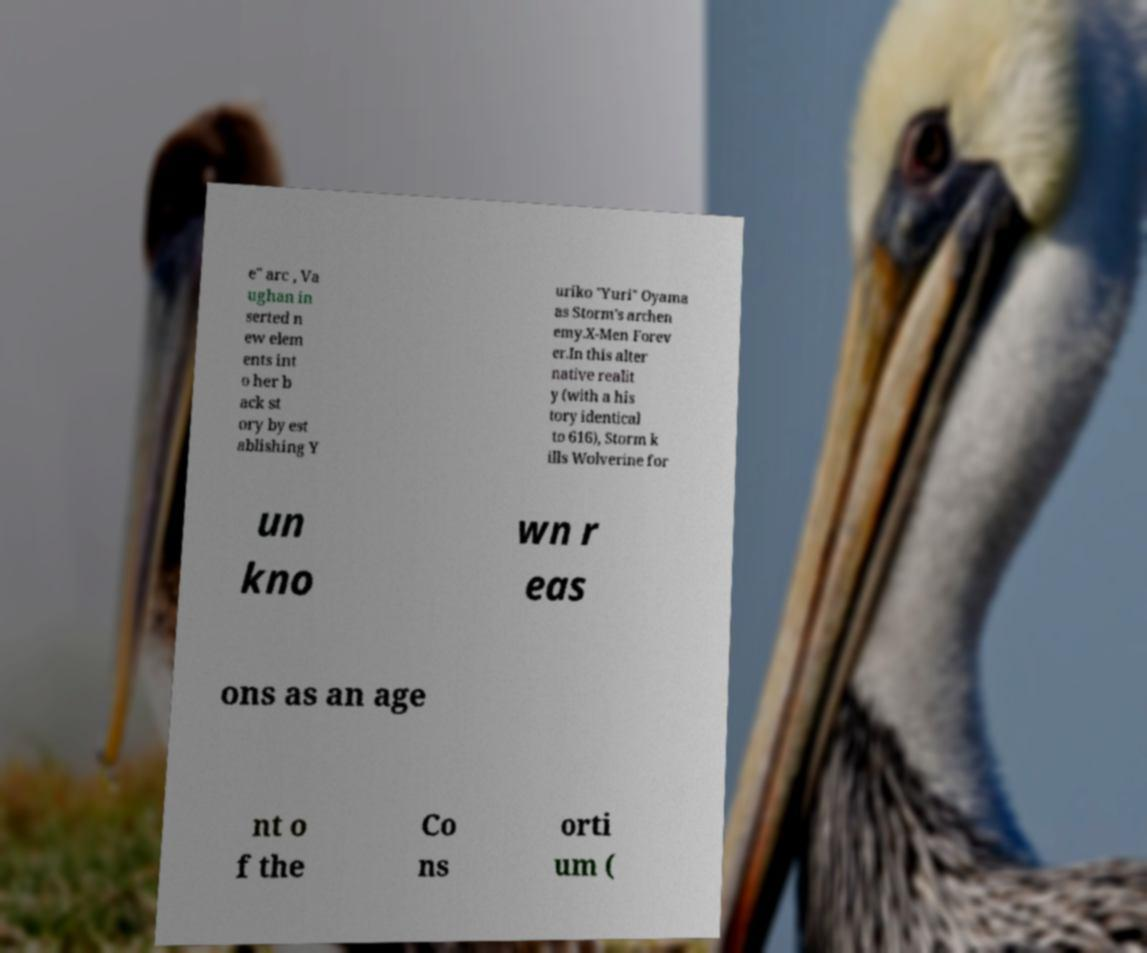I need the written content from this picture converted into text. Can you do that? e" arc , Va ughan in serted n ew elem ents int o her b ack st ory by est ablishing Y uriko "Yuri" Oyama as Storm's archen emy.X-Men Forev er.In this alter native realit y (with a his tory identical to 616), Storm k ills Wolverine for un kno wn r eas ons as an age nt o f the Co ns orti um ( 